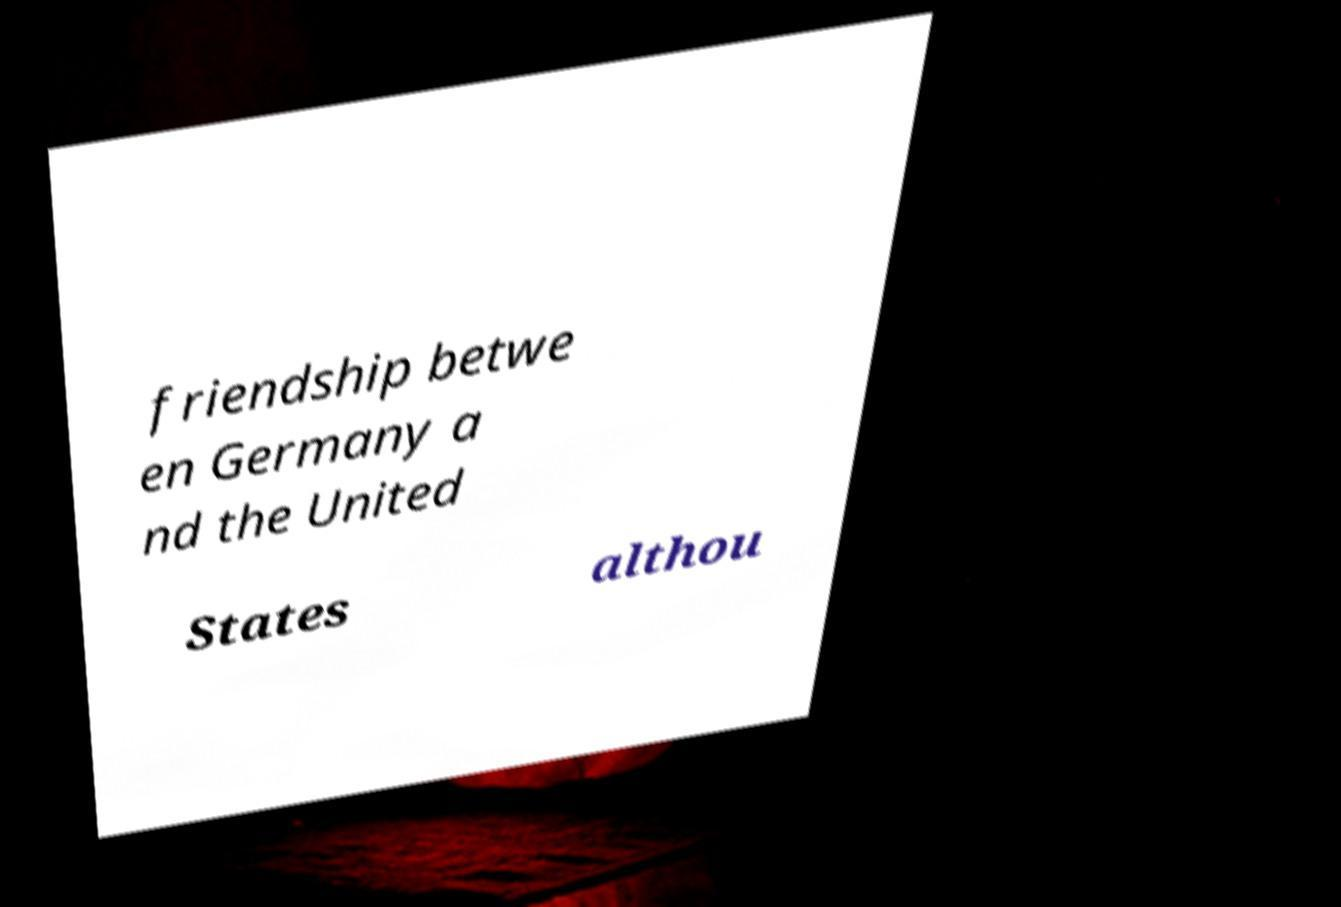Could you extract and type out the text from this image? friendship betwe en Germany a nd the United States althou 